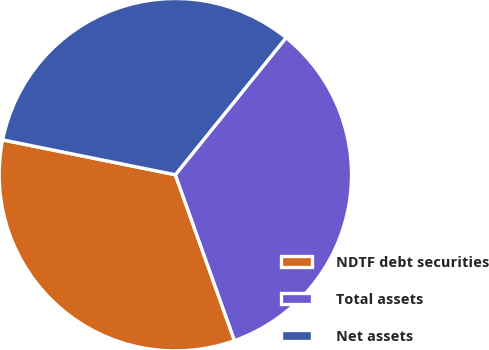<chart> <loc_0><loc_0><loc_500><loc_500><pie_chart><fcel>NDTF debt securities<fcel>Total assets<fcel>Net assets<nl><fcel>33.62%<fcel>33.73%<fcel>32.65%<nl></chart> 